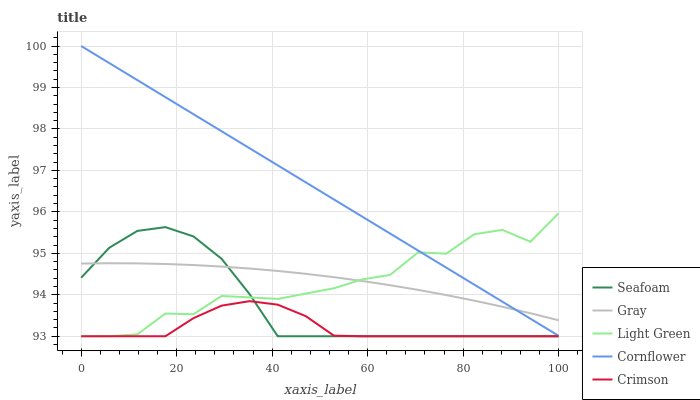Does Crimson have the minimum area under the curve?
Answer yes or no. Yes. Does Cornflower have the maximum area under the curve?
Answer yes or no. Yes. Does Gray have the minimum area under the curve?
Answer yes or no. No. Does Gray have the maximum area under the curve?
Answer yes or no. No. Is Cornflower the smoothest?
Answer yes or no. Yes. Is Light Green the roughest?
Answer yes or no. Yes. Is Gray the smoothest?
Answer yes or no. No. Is Gray the roughest?
Answer yes or no. No. Does Gray have the lowest value?
Answer yes or no. No. Does Gray have the highest value?
Answer yes or no. No. Is Seafoam less than Cornflower?
Answer yes or no. Yes. Is Cornflower greater than Crimson?
Answer yes or no. Yes. Does Seafoam intersect Cornflower?
Answer yes or no. No. 